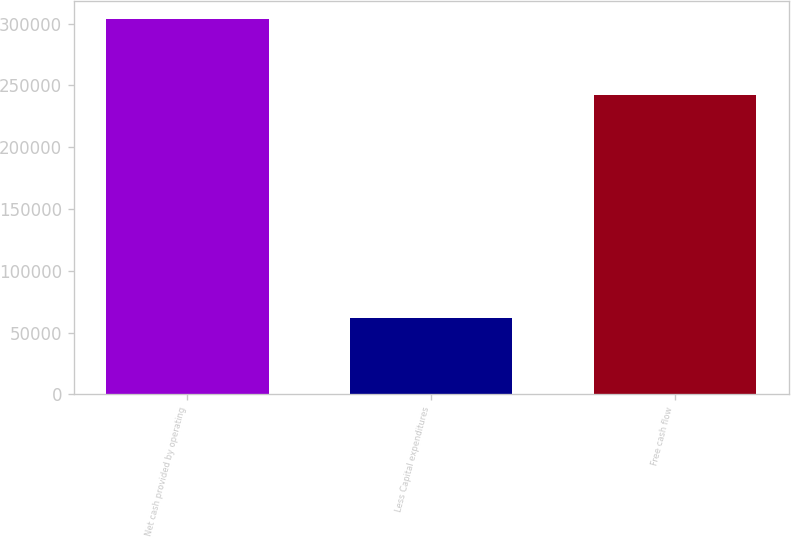<chart> <loc_0><loc_0><loc_500><loc_500><bar_chart><fcel>Net cash provided by operating<fcel>Less Capital expenditures<fcel>Free cash flow<nl><fcel>303446<fcel>61448<fcel>241998<nl></chart> 